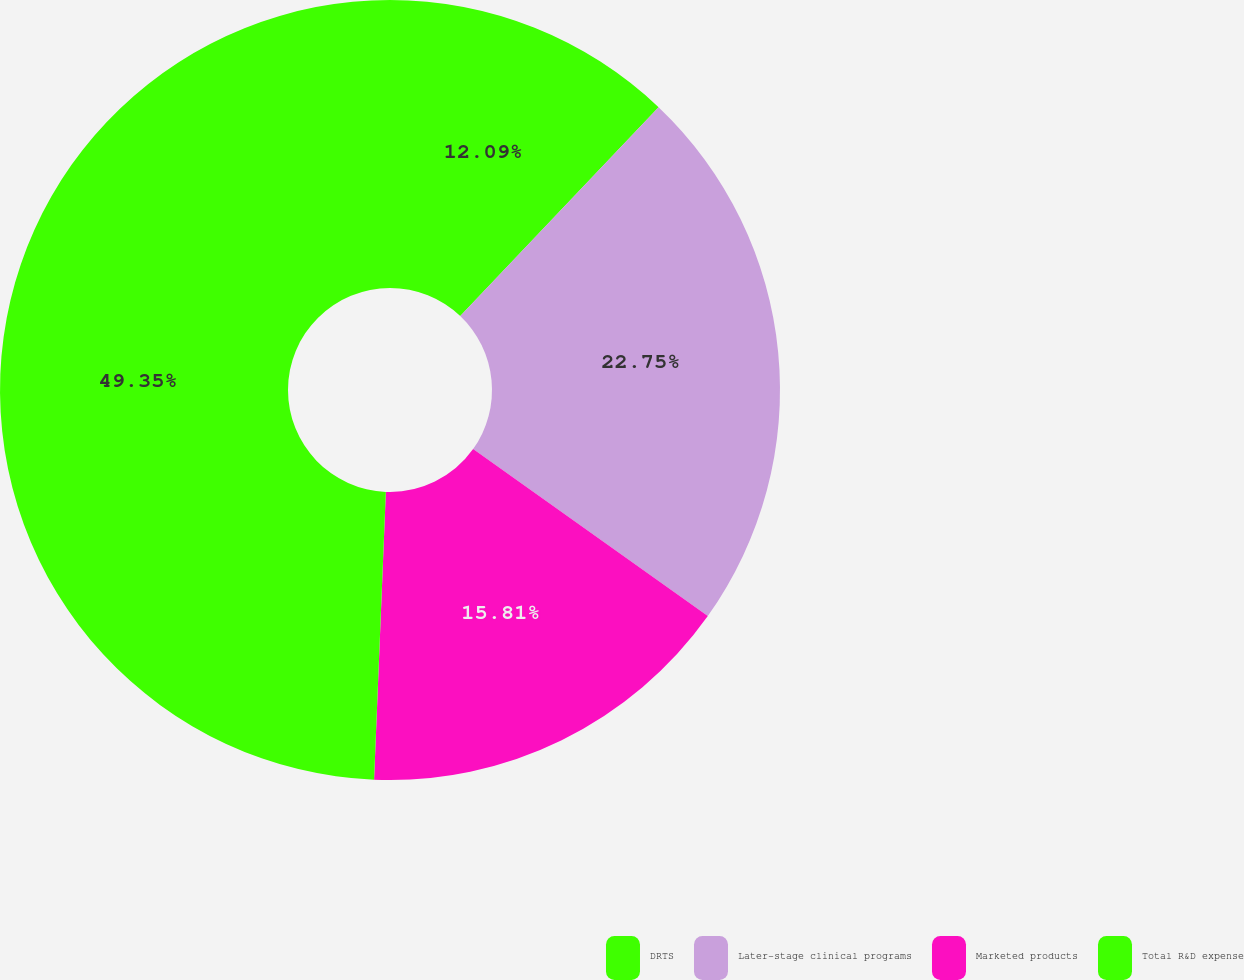Convert chart to OTSL. <chart><loc_0><loc_0><loc_500><loc_500><pie_chart><fcel>DRTS<fcel>Later-stage clinical programs<fcel>Marketed products<fcel>Total R&D expense<nl><fcel>12.09%<fcel>22.75%<fcel>15.81%<fcel>49.35%<nl></chart> 